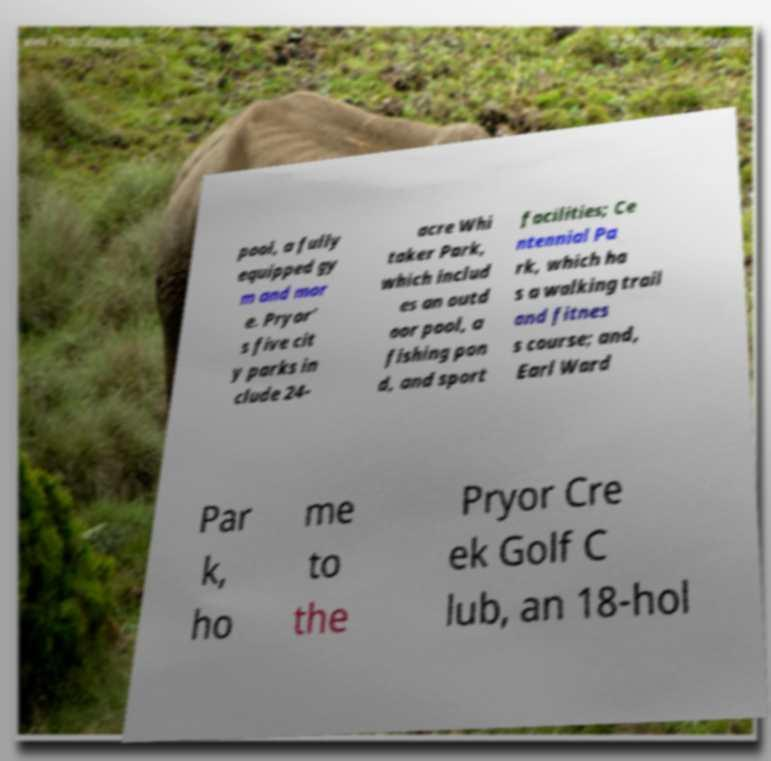There's text embedded in this image that I need extracted. Can you transcribe it verbatim? pool, a fully equipped gy m and mor e. Pryor' s five cit y parks in clude 24- acre Whi taker Park, which includ es an outd oor pool, a fishing pon d, and sport facilities; Ce ntennial Pa rk, which ha s a walking trail and fitnes s course; and, Earl Ward Par k, ho me to the Pryor Cre ek Golf C lub, an 18-hol 